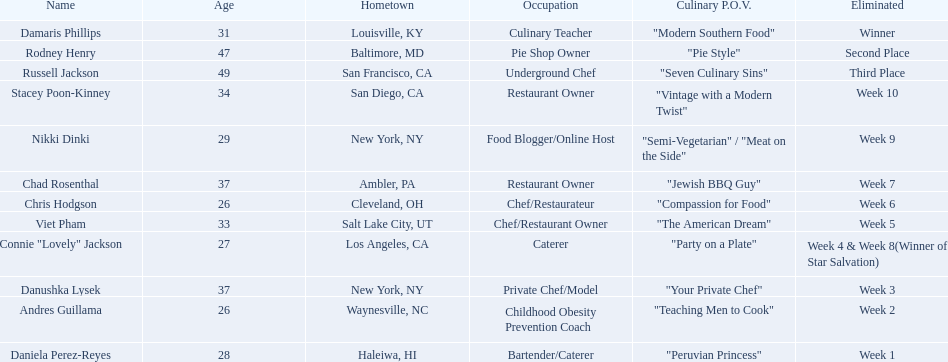Could you list all the competitors? Damaris Phillips, Rodney Henry, Russell Jackson, Stacey Poon-Kinney, Nikki Dinki, Chad Rosenthal, Chris Hodgson, Viet Pham, Connie "Lovely" Jackson, Danushka Lysek, Andres Guillama, Daniela Perez-Reyes. Which one has a culinary point of view that goes beyond the fusion of traditional and modern aspects? "Semi-Vegetarian" / "Meat on the Side". Who among them adopts a semi-vegetarian or meat-as-a-side-dish perspective? Nikki Dinki. 